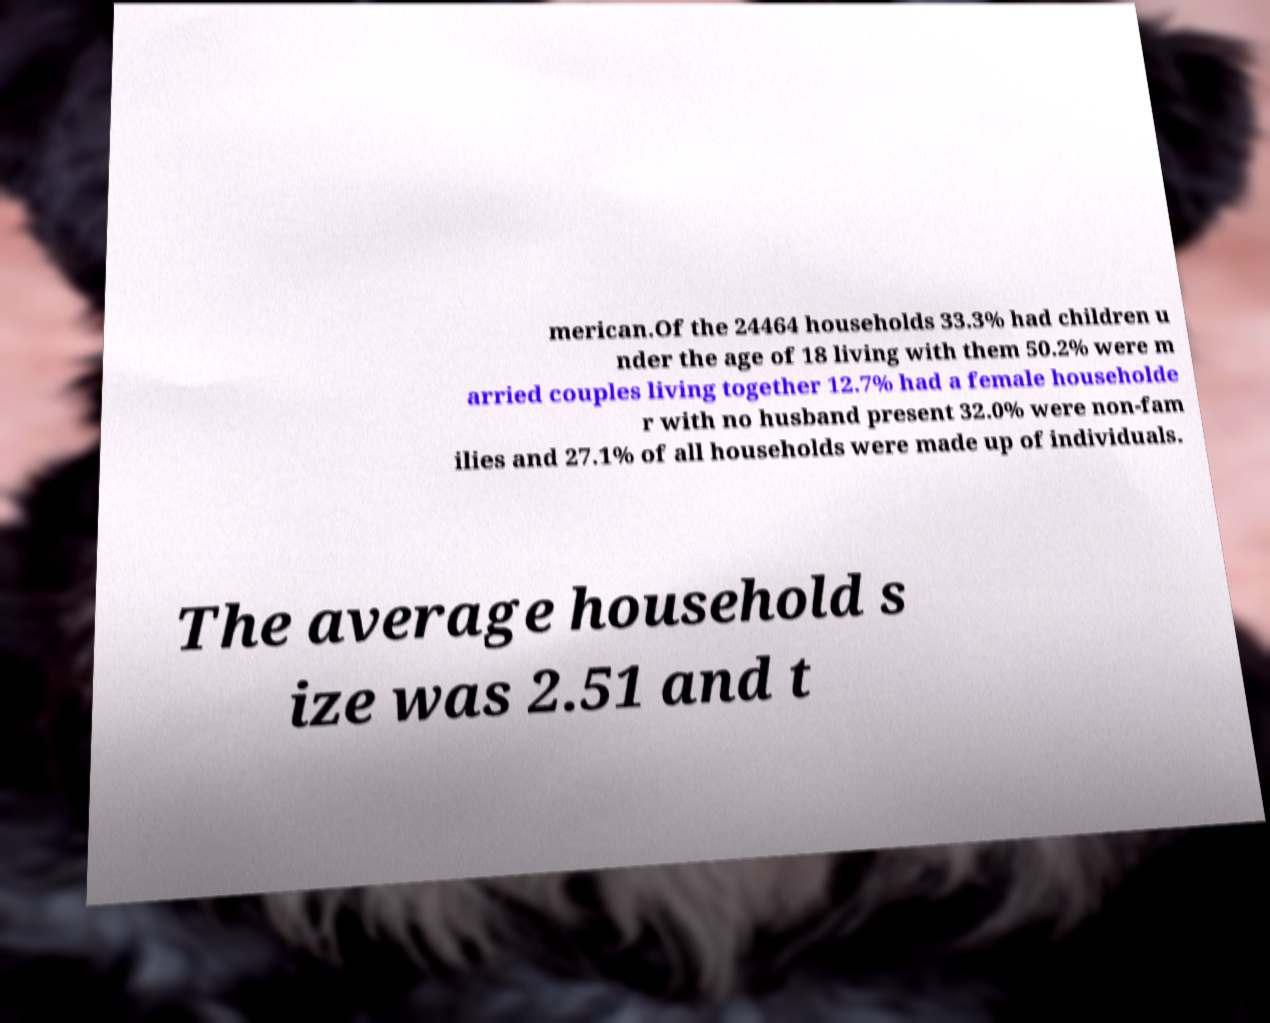For documentation purposes, I need the text within this image transcribed. Could you provide that? merican.Of the 24464 households 33.3% had children u nder the age of 18 living with them 50.2% were m arried couples living together 12.7% had a female householde r with no husband present 32.0% were non-fam ilies and 27.1% of all households were made up of individuals. The average household s ize was 2.51 and t 